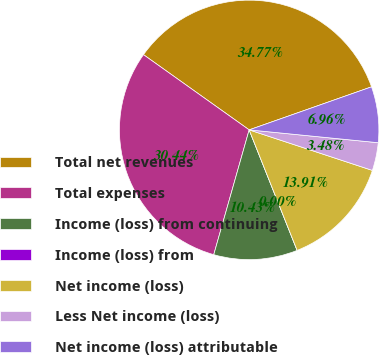<chart> <loc_0><loc_0><loc_500><loc_500><pie_chart><fcel>Total net revenues<fcel>Total expenses<fcel>Income (loss) from continuing<fcel>Income (loss) from<fcel>Net income (loss)<fcel>Less Net income (loss)<fcel>Net income (loss) attributable<nl><fcel>34.77%<fcel>30.44%<fcel>10.43%<fcel>0.0%<fcel>13.91%<fcel>3.48%<fcel>6.96%<nl></chart> 